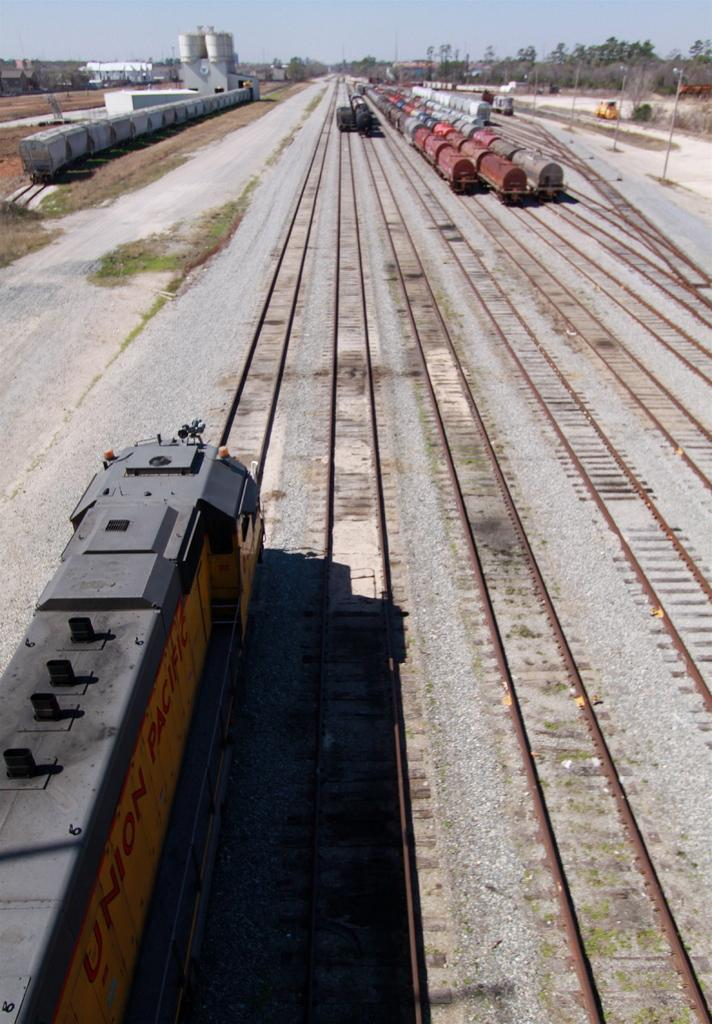What type of vehicles can be seen in the image? There are trains on railway tracks in the image. Where are the railway tracks located? The railway tracks are on the ground. What type of structures are present in the image? There are sheds in the image. What type of vegetation is present in the image? Trees and grass are visible in the image. What type of vertical structures are present in the image? Poles are present in the image. What other objects can be seen in the image? There are other objects in the image, but their specific details are not mentioned in the provided facts. What can be seen in the background of the image? The sky is visible in the background of the image. What type of crack can be heard in the image? There is no sound or crack present in the image; it is a still image of trains on railway tracks. 